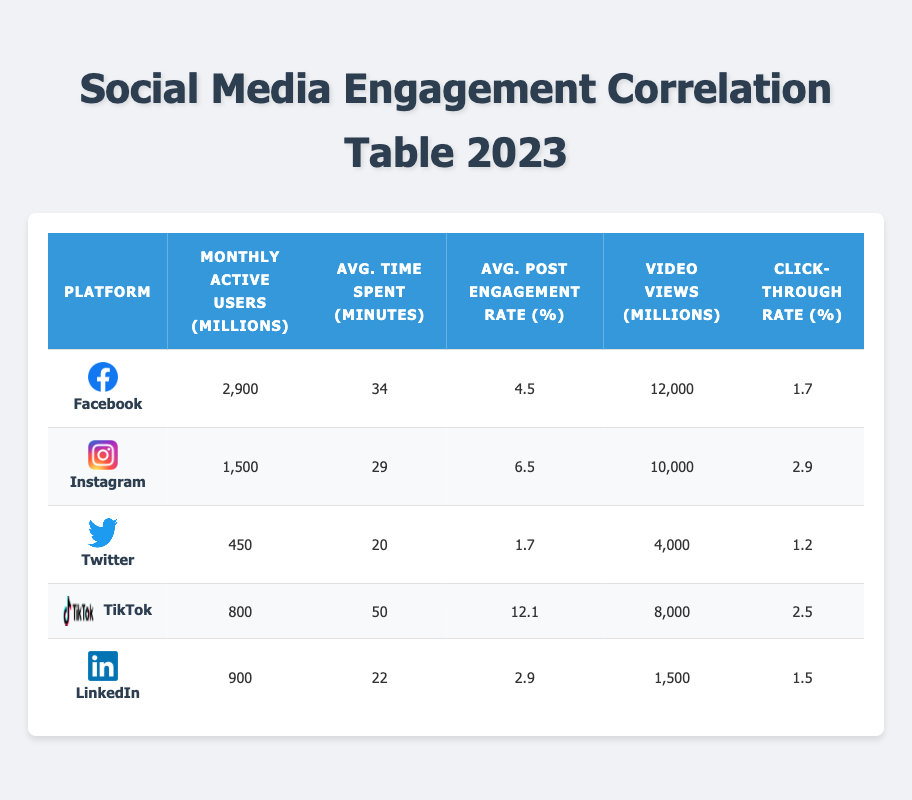What is the average time spent per user on TikTok? From the table, the average time spent per user on TikTok is listed as 50 minutes.
Answer: 50 minutes Which social media platform has the highest average post engagement rate? TikTok has the highest average post engagement rate of 12.1%, which is higher than Facebook (4.5%), Instagram (6.5%), Twitter (1.7%), and LinkedIn (2.9%).
Answer: TikTok Is the click-through rate for Instagram higher than that of LinkedIn? Yes, Instagram's click-through rate is 2.9%, which is higher than LinkedIn's 1.5%.
Answer: Yes What is the difference in monthly active users between Facebook and Twitter? Facebook has 2,900 million monthly active users while Twitter has 450 million. The difference is calculated as 2,900 - 450 = 2,450 million.
Answer: 2,450 million Which platform has fewer monthly active users than TikTok? Twitter (450 million) and LinkedIn (900 million) both have fewer monthly active users than TikTok, which has 800 million.
Answer: Twitter and LinkedIn What is the average engagement rate of the top three social media platforms (Facebook, Instagram, and TikTok)? The average engagement rate is calculated as follows: (4.5 + 6.5 + 12.1) / 3 = 7.7%.
Answer: 7.7% Does having more monthly active users correlate with a higher click-through rate? No, as seen in the table; despite Facebook having the most users (2,900 million), it has a lower click-through rate (1.7%) than Instagram (2.9%) and TikTok (2.5%), which have fewer users.
Answer: No Calculate the sum of video views for all platforms. The sum of video views is: 12000 + 10000 + 4000 + 8000 + 1500 = 40000 million.
Answer: 40000 million Which platform has the lowest average time spent per user? Twitter has the lowest average time spent per user at 20 minutes, compared to the other platforms.
Answer: Twitter 